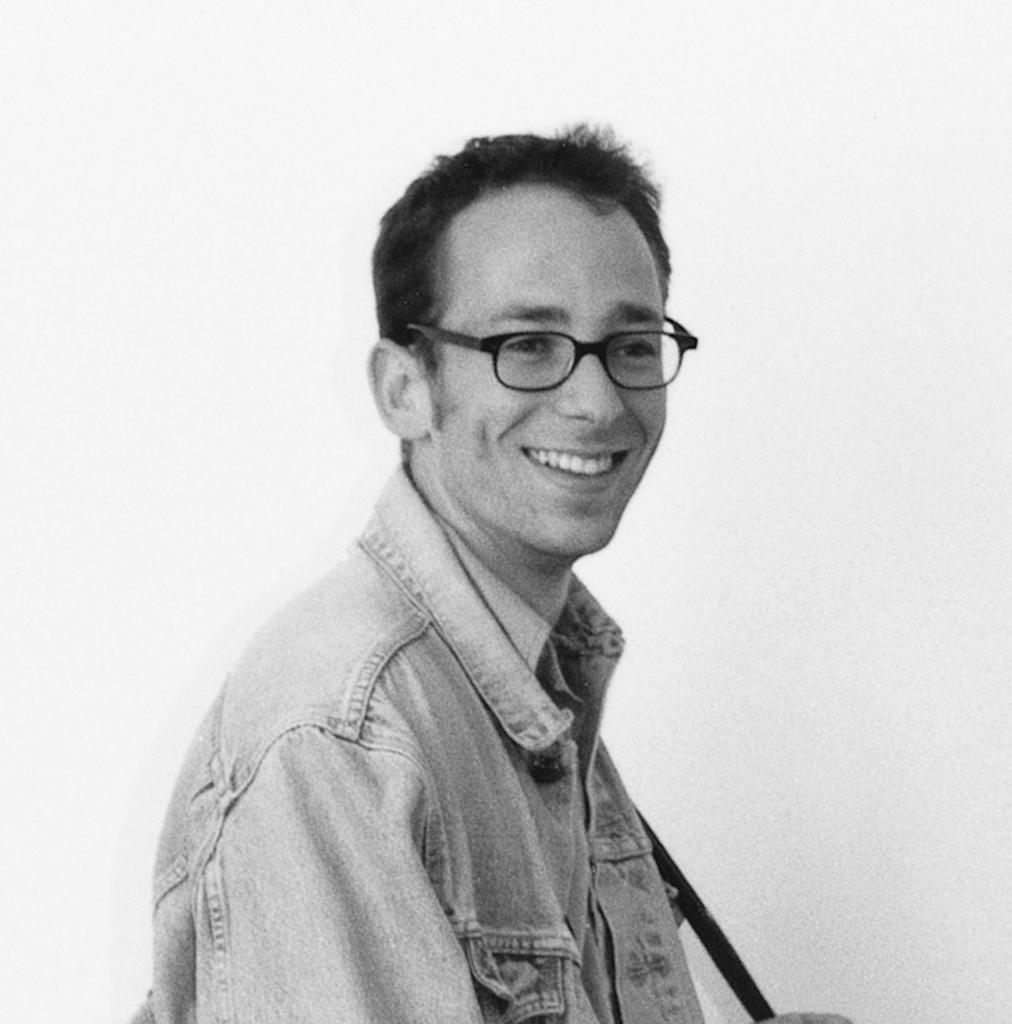What is the color of the wall in the image? The wall in the image is white. Who is present in the image? There is a man in the image. What is the man wearing in the image? The man is wearing spectacles. What type of rod can be seen holding up the wall in the image? There is no rod present in the image; it is a wall without any visible support. 